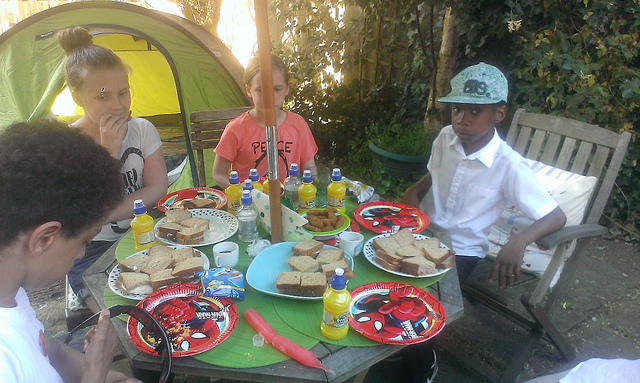Please identify all text content in this image. PE CE 